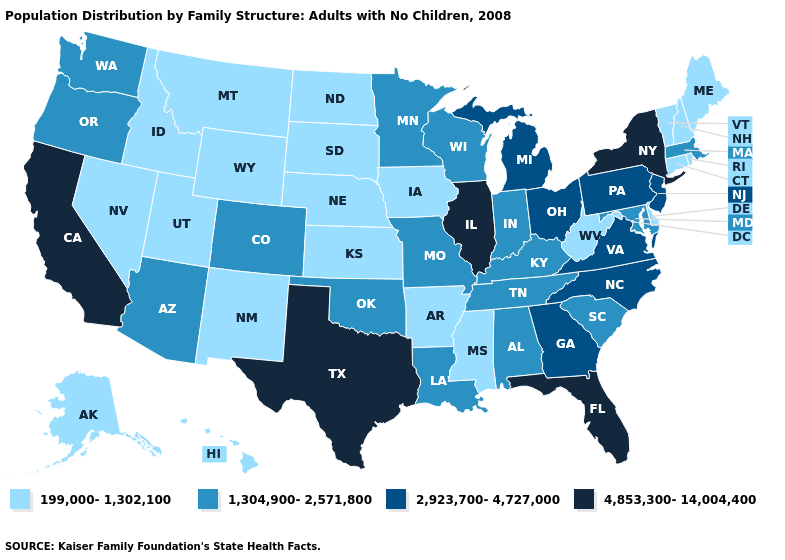Does Tennessee have a higher value than Rhode Island?
Write a very short answer. Yes. What is the value of Wisconsin?
Be succinct. 1,304,900-2,571,800. What is the value of Idaho?
Write a very short answer. 199,000-1,302,100. Does Delaware have the lowest value in the South?
Concise answer only. Yes. Does Nebraska have the lowest value in the MidWest?
Keep it brief. Yes. Name the states that have a value in the range 1,304,900-2,571,800?
Be succinct. Alabama, Arizona, Colorado, Indiana, Kentucky, Louisiana, Maryland, Massachusetts, Minnesota, Missouri, Oklahoma, Oregon, South Carolina, Tennessee, Washington, Wisconsin. Which states hav the highest value in the MidWest?
Be succinct. Illinois. Name the states that have a value in the range 1,304,900-2,571,800?
Concise answer only. Alabama, Arizona, Colorado, Indiana, Kentucky, Louisiana, Maryland, Massachusetts, Minnesota, Missouri, Oklahoma, Oregon, South Carolina, Tennessee, Washington, Wisconsin. Name the states that have a value in the range 2,923,700-4,727,000?
Short answer required. Georgia, Michigan, New Jersey, North Carolina, Ohio, Pennsylvania, Virginia. Does Colorado have a higher value than Michigan?
Keep it brief. No. Which states hav the highest value in the MidWest?
Keep it brief. Illinois. Name the states that have a value in the range 4,853,300-14,004,400?
Answer briefly. California, Florida, Illinois, New York, Texas. What is the lowest value in states that border Delaware?
Short answer required. 1,304,900-2,571,800. Does Iowa have the lowest value in the MidWest?
Answer briefly. Yes. What is the lowest value in the USA?
Answer briefly. 199,000-1,302,100. 